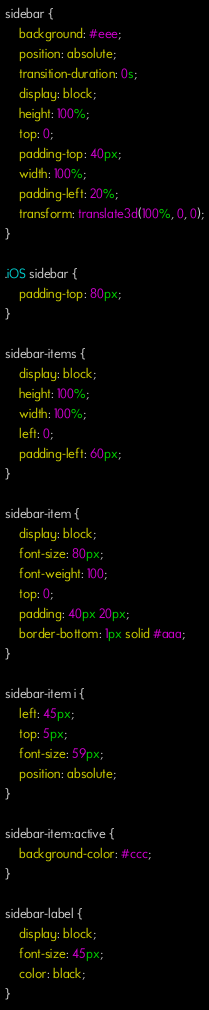<code> <loc_0><loc_0><loc_500><loc_500><_CSS_>sidebar {
    background: #eee;
    position: absolute;
    transition-duration: 0s;
    display: block;
    height: 100%;
    top: 0;
    padding-top: 40px;
    width: 100%;
    padding-left: 20%;
    transform: translate3d(100%, 0, 0);
}

.iOS sidebar {
    padding-top: 80px;
}

sidebar-items {
    display: block;
    height: 100%;
    width: 100%;
    left: 0;
    padding-left: 60px;
}

sidebar-item {
    display: block;
    font-size: 80px;
    font-weight: 100;
    top: 0;
    padding: 40px 20px;
    border-bottom: 1px solid #aaa;
}

sidebar-item i {
    left: 45px;
    top: 5px;
    font-size: 59px;
    position: absolute;
}

sidebar-item:active {
    background-color: #ccc;
}

sidebar-label {
    display: block;
    font-size: 45px;
    color: black;
}
</code> 